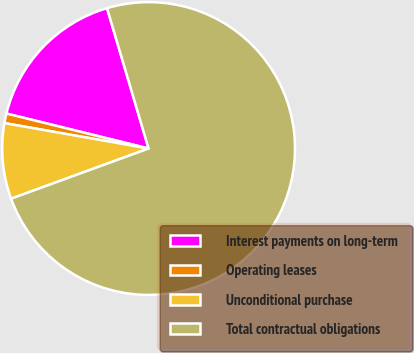<chart> <loc_0><loc_0><loc_500><loc_500><pie_chart><fcel>Interest payments on long-term<fcel>Operating leases<fcel>Unconditional purchase<fcel>Total contractual obligations<nl><fcel>16.58%<fcel>1.06%<fcel>8.35%<fcel>74.01%<nl></chart> 